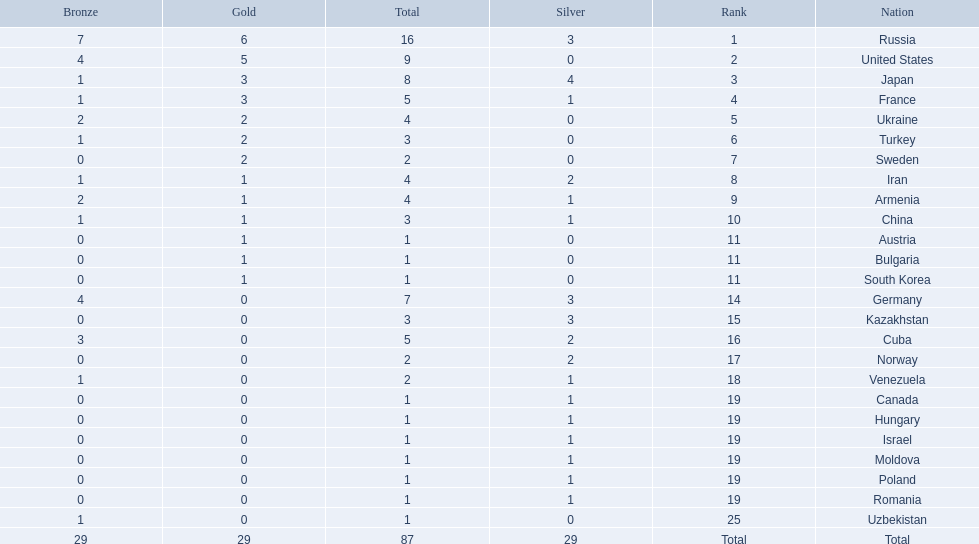Which nations participated in the championships? Russia, United States, Japan, France, Ukraine, Turkey, Sweden, Iran, Armenia, China, Austria, Bulgaria, South Korea, Germany, Kazakhstan, Cuba, Norway, Venezuela, Canada, Hungary, Israel, Moldova, Poland, Romania, Uzbekistan. How many bronze medals did they receive? 7, 4, 1, 1, 2, 1, 0, 1, 2, 1, 0, 0, 0, 4, 0, 3, 0, 1, 0, 0, 0, 0, 0, 0, 1, 29. How many in total? 16, 9, 8, 5, 4, 3, 2, 4, 4, 3, 1, 1, 1, 7, 3, 5, 2, 2, 1, 1, 1, 1, 1, 1, 1. And which team won only one medal -- the bronze? Uzbekistan. 